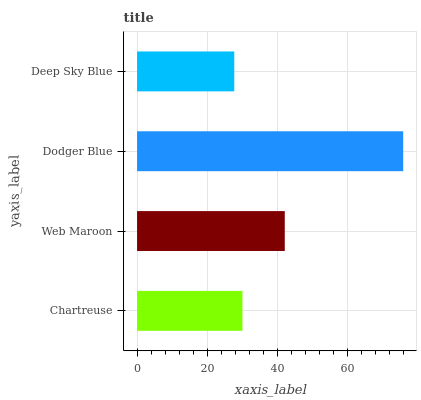Is Deep Sky Blue the minimum?
Answer yes or no. Yes. Is Dodger Blue the maximum?
Answer yes or no. Yes. Is Web Maroon the minimum?
Answer yes or no. No. Is Web Maroon the maximum?
Answer yes or no. No. Is Web Maroon greater than Chartreuse?
Answer yes or no. Yes. Is Chartreuse less than Web Maroon?
Answer yes or no. Yes. Is Chartreuse greater than Web Maroon?
Answer yes or no. No. Is Web Maroon less than Chartreuse?
Answer yes or no. No. Is Web Maroon the high median?
Answer yes or no. Yes. Is Chartreuse the low median?
Answer yes or no. Yes. Is Dodger Blue the high median?
Answer yes or no. No. Is Deep Sky Blue the low median?
Answer yes or no. No. 